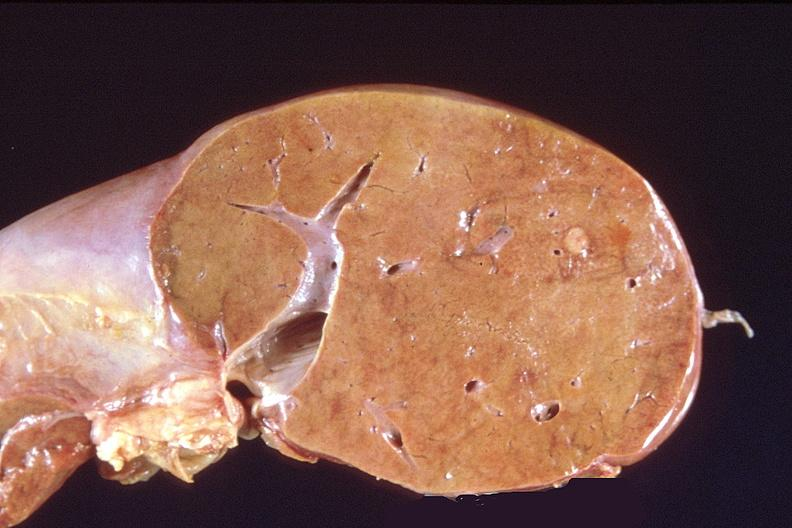what does this image show?
Answer the question using a single word or phrase. Liver 